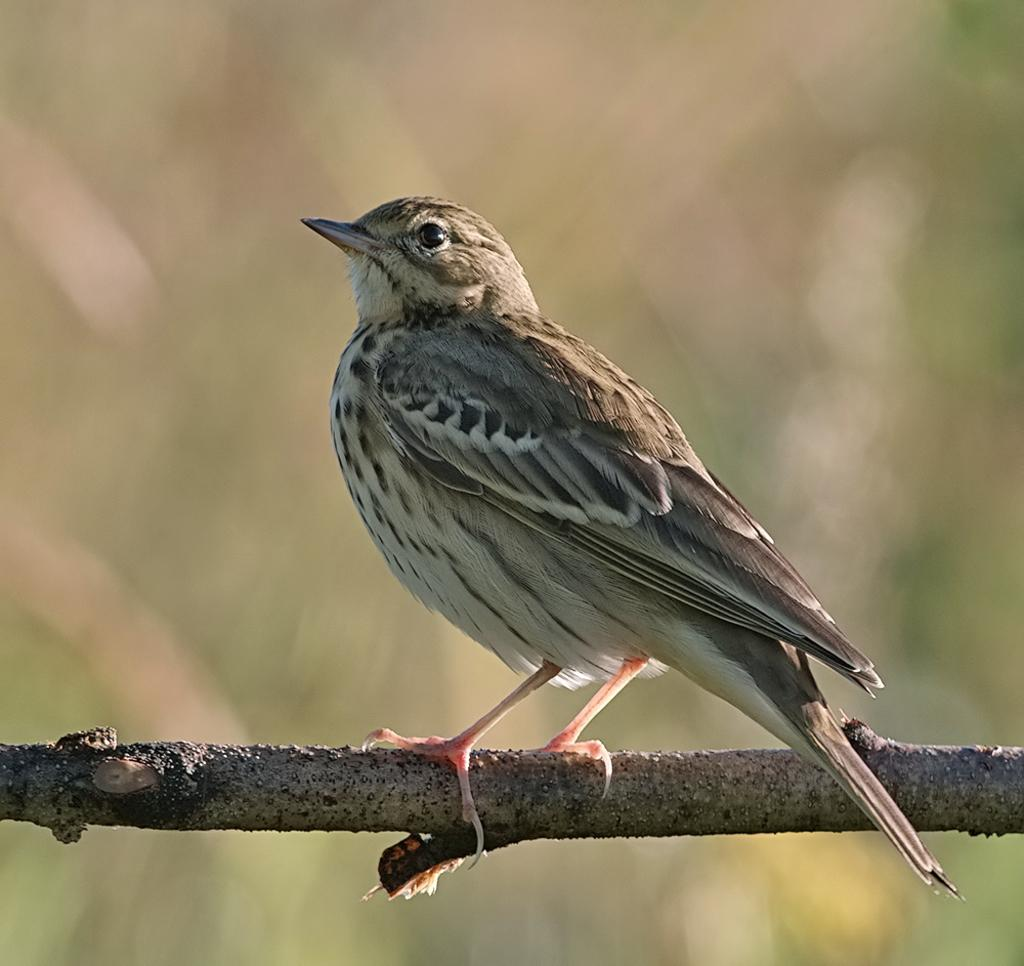What type of animal can be seen in the image? There is a bird in the image. Where is the bird located in the image? The bird is on a branch of a tree. How many geese are present in the image? There are no geese present in the image; it features a bird on a tree branch. What type of map can be seen in the image? There is no map present in the image. 